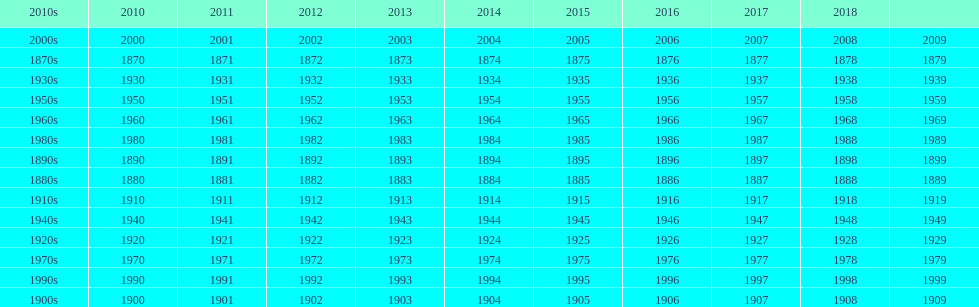Parse the full table. {'header': ['2010s', '2010', '2011', '2012', '2013', '2014', '2015', '2016', '2017', '2018', ''], 'rows': [['2000s', '2000', '2001', '2002', '2003', '2004', '2005', '2006', '2007', '2008', '2009'], ['1870s', '1870', '1871', '1872', '1873', '1874', '1875', '1876', '1877', '1878', '1879'], ['1930s', '1930', '1931', '1932', '1933', '1934', '1935', '1936', '1937', '1938', '1939'], ['1950s', '1950', '1951', '1952', '1953', '1954', '1955', '1956', '1957', '1958', '1959'], ['1960s', '1960', '1961', '1962', '1963', '1964', '1965', '1966', '1967', '1968', '1969'], ['1980s', '1980', '1981', '1982', '1983', '1984', '1985', '1986', '1987', '1988', '1989'], ['1890s', '1890', '1891', '1892', '1893', '1894', '1895', '1896', '1897', '1898', '1899'], ['1880s', '1880', '1881', '1882', '1883', '1884', '1885', '1886', '1887', '1888', '1889'], ['1910s', '1910', '1911', '1912', '1913', '1914', '1915', '1916', '1917', '1918', '1919'], ['1940s', '1940', '1941', '1942', '1943', '1944', '1945', '1946', '1947', '1948', '1949'], ['1920s', '1920', '1921', '1922', '1923', '1924', '1925', '1926', '1927', '1928', '1929'], ['1970s', '1970', '1971', '1972', '1973', '1974', '1975', '1976', '1977', '1978', '1979'], ['1990s', '1990', '1991', '1992', '1993', '1994', '1995', '1996', '1997', '1998', '1999'], ['1900s', '1900', '1901', '1902', '1903', '1904', '1905', '1906', '1907', '1908', '1909']]} True/false: all years go in consecutive order? True. 